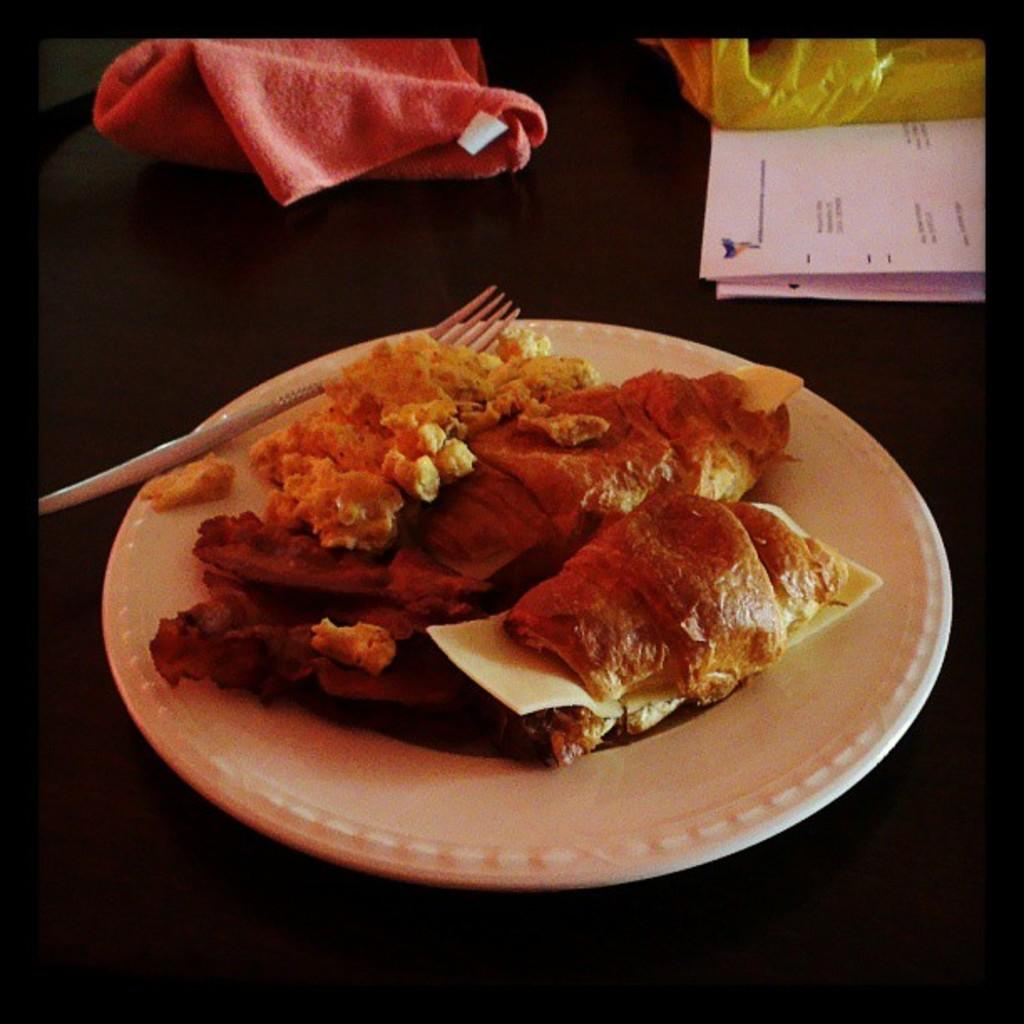What is the main piece of furniture in the image? There is a table in the image. What items can be seen on the table? There are papers, clothes, a plate, food, and a fork on the table. What is the purpose of the plate on the table? The plate is used to hold food. What utensil is present on the table? There is a fork on the table. What type of sleet can be seen falling outside the window in the image? There is no window or sleet present in the image; it only features a table with various items on it. 